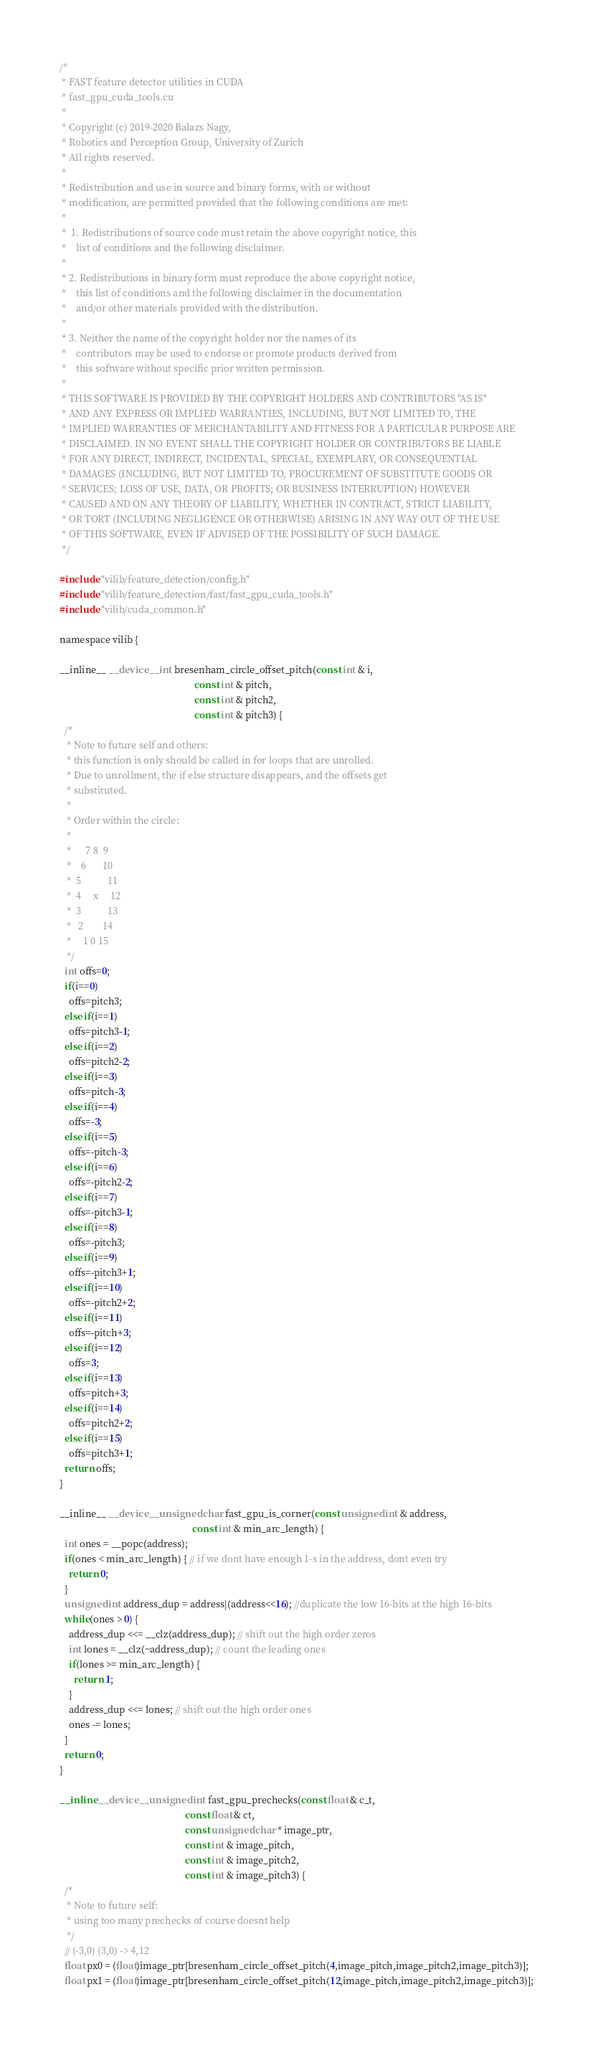<code> <loc_0><loc_0><loc_500><loc_500><_Cuda_>/*
 * FAST feature detector utilities in CUDA
 * fast_gpu_cuda_tools.cu
 *
 * Copyright (c) 2019-2020 Balazs Nagy,
 * Robotics and Perception Group, University of Zurich
 * All rights reserved.
 * 
 * Redistribution and use in source and binary forms, with or without
 * modification, are permitted provided that the following conditions are met:
 * 
 *  1. Redistributions of source code must retain the above copyright notice, this
 *    list of conditions and the following disclaimer.
 * 
 * 2. Redistributions in binary form must reproduce the above copyright notice,
 *    this list of conditions and the following disclaimer in the documentation
 *    and/or other materials provided with the distribution.
 * 
 * 3. Neither the name of the copyright holder nor the names of its
 *    contributors may be used to endorse or promote products derived from
 *    this software without specific prior written permission.
 * 
 * THIS SOFTWARE IS PROVIDED BY THE COPYRIGHT HOLDERS AND CONTRIBUTORS "AS IS"
 * AND ANY EXPRESS OR IMPLIED WARRANTIES, INCLUDING, BUT NOT LIMITED TO, THE
 * IMPLIED WARRANTIES OF MERCHANTABILITY AND FITNESS FOR A PARTICULAR PURPOSE ARE
 * DISCLAIMED. IN NO EVENT SHALL THE COPYRIGHT HOLDER OR CONTRIBUTORS BE LIABLE
 * FOR ANY DIRECT, INDIRECT, INCIDENTAL, SPECIAL, EXEMPLARY, OR CONSEQUENTIAL
 * DAMAGES (INCLUDING, BUT NOT LIMITED TO, PROCUREMENT OF SUBSTITUTE GOODS OR
 * SERVICES; LOSS OF USE, DATA, OR PROFITS; OR BUSINESS INTERRUPTION) HOWEVER
 * CAUSED AND ON ANY THEORY OF LIABILITY, WHETHER IN CONTRACT, STRICT LIABILITY,
 * OR TORT (INCLUDING NEGLIGENCE OR OTHERWISE) ARISING IN ANY WAY OUT OF THE USE
 * OF THIS SOFTWARE, EVEN IF ADVISED OF THE POSSIBILITY OF SUCH DAMAGE.
 */

#include "vilib/feature_detection/config.h"
#include "vilib/feature_detection/fast/fast_gpu_cuda_tools.h"
#include "vilib/cuda_common.h"

namespace vilib {

__inline__ __device__ int bresenham_circle_offset_pitch(const int & i,
                                                        const int & pitch,
                                                        const int & pitch2,
                                                        const int & pitch3) {
  /*
   * Note to future self and others:
   * this function is only should be called in for loops that are unrolled.
   * Due to unrollment, the if else structure disappears, and the offsets get
   * substituted.
   *
   * Order within the circle:
   *
   *      7 8  9
   *    6       10
   *  5           11
   *  4     x     12
   *  3           13
   *   2        14
   *     1 0 15
   */
  int offs=0;
  if(i==0)
    offs=pitch3;
  else if(i==1)
    offs=pitch3-1;
  else if(i==2)
    offs=pitch2-2;
  else if(i==3)
    offs=pitch-3;
  else if(i==4)
    offs=-3;
  else if(i==5)
    offs=-pitch-3;
  else if(i==6)
    offs=-pitch2-2;
  else if(i==7)
    offs=-pitch3-1;
  else if(i==8)
    offs=-pitch3;
  else if(i==9)
    offs=-pitch3+1;
  else if(i==10)
    offs=-pitch2+2;
  else if(i==11)
    offs=-pitch+3;
  else if(i==12)
    offs=3;
  else if(i==13)
    offs=pitch+3;
  else if(i==14)
    offs=pitch2+2;
  else if(i==15)
    offs=pitch3+1;
  return offs;
}

__inline__ __device__ unsigned char fast_gpu_is_corner(const unsigned int & address,
                                                       const int & min_arc_length) {
  int ones = __popc(address);
  if(ones < min_arc_length) { // if we dont have enough 1-s in the address, dont even try
    return 0;
  }
  unsigned int address_dup = address|(address<<16); //duplicate the low 16-bits at the high 16-bits
  while(ones > 0) {
    address_dup <<= __clz(address_dup); // shift out the high order zeros
    int lones = __clz(~address_dup); // count the leading ones
    if(lones >= min_arc_length) {
      return 1;
    }
    address_dup <<= lones; // shift out the high order ones
    ones -= lones;
  }
  return 0;
}

__inline __device__ unsigned int fast_gpu_prechecks(const float & c_t,
                                                    const float & ct,
                                                    const unsigned char * image_ptr,
                                                    const int & image_pitch,
                                                    const int & image_pitch2,
                                                    const int & image_pitch3) {
  /*
   * Note to future self:
   * using too many prechecks of course doesnt help
   */
  // (-3,0) (3,0) -> 4,12
  float px0 = (float)image_ptr[bresenham_circle_offset_pitch(4,image_pitch,image_pitch2,image_pitch3)];
  float px1 = (float)image_ptr[bresenham_circle_offset_pitch(12,image_pitch,image_pitch2,image_pitch3)];</code> 